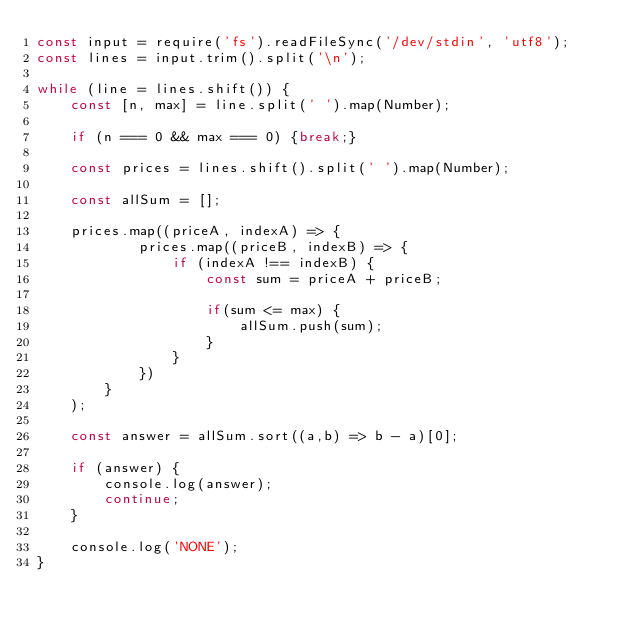Convert code to text. <code><loc_0><loc_0><loc_500><loc_500><_JavaScript_>const input = require('fs').readFileSync('/dev/stdin', 'utf8');
const lines = input.trim().split('\n');

while (line = lines.shift()) {
	const [n, max] = line.split(' ').map(Number);

	if (n === 0 && max === 0) {break;}

	const prices = lines.shift().split(' ').map(Number);

	const allSum = [];

	prices.map((priceA, indexA) => {
			prices.map((priceB, indexB) => {
				if (indexA !== indexB) {
					const sum = priceA + priceB;

					if(sum <= max) {
						allSum.push(sum);
					}
				}
			})
		}
	);

	const answer = allSum.sort((a,b) => b - a)[0];

	if (answer) {
		console.log(answer);
		continue;
	}

	console.log('NONE');
}

</code> 